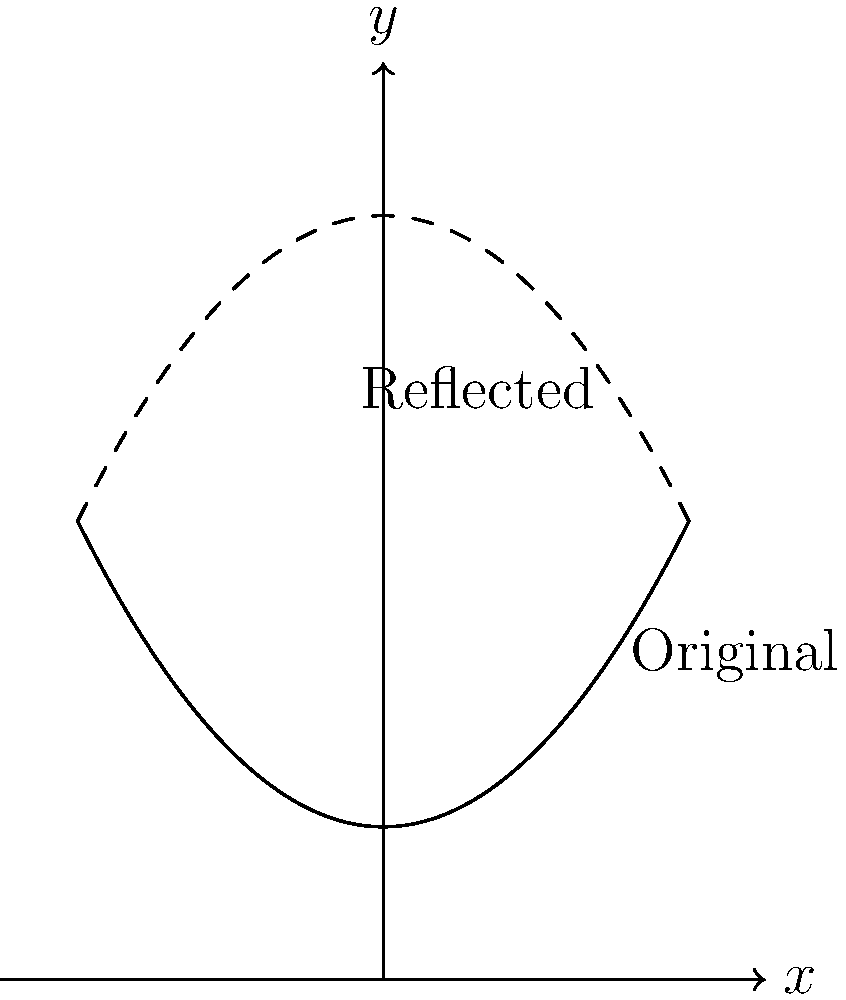The solid curve represents voter turnout in your local district over time. If this graph is reflected across the line $y = 3$, which equation represents the new reflected graph (shown as the dashed curve)? To solve this problem, let's follow these steps:

1) The original function is in the form $f(x) = 0.5x^2 + 1$. This is a parabola opening upwards with its vertex at (0, 1).

2) To reflect a graph across the line $y = k$, we use the transformation $g(x) = 2k - f(x)$.

3) In this case, $k = 3$, so our transformation will be:
   $g(x) = 2(3) - f(x) = 6 - f(x)$

4) Substituting the original function:
   $g(x) = 6 - (0.5x^2 + 1)$

5) Simplifying:
   $g(x) = 6 - 0.5x^2 - 1$
   $g(x) = 5 - 0.5x^2$
   $g(x) = -0.5x^2 + 5$

This final equation represents the reflected graph. It's a parabola opening downwards with its vertex at (0, 5).
Answer: $g(x) = -0.5x^2 + 5$ 